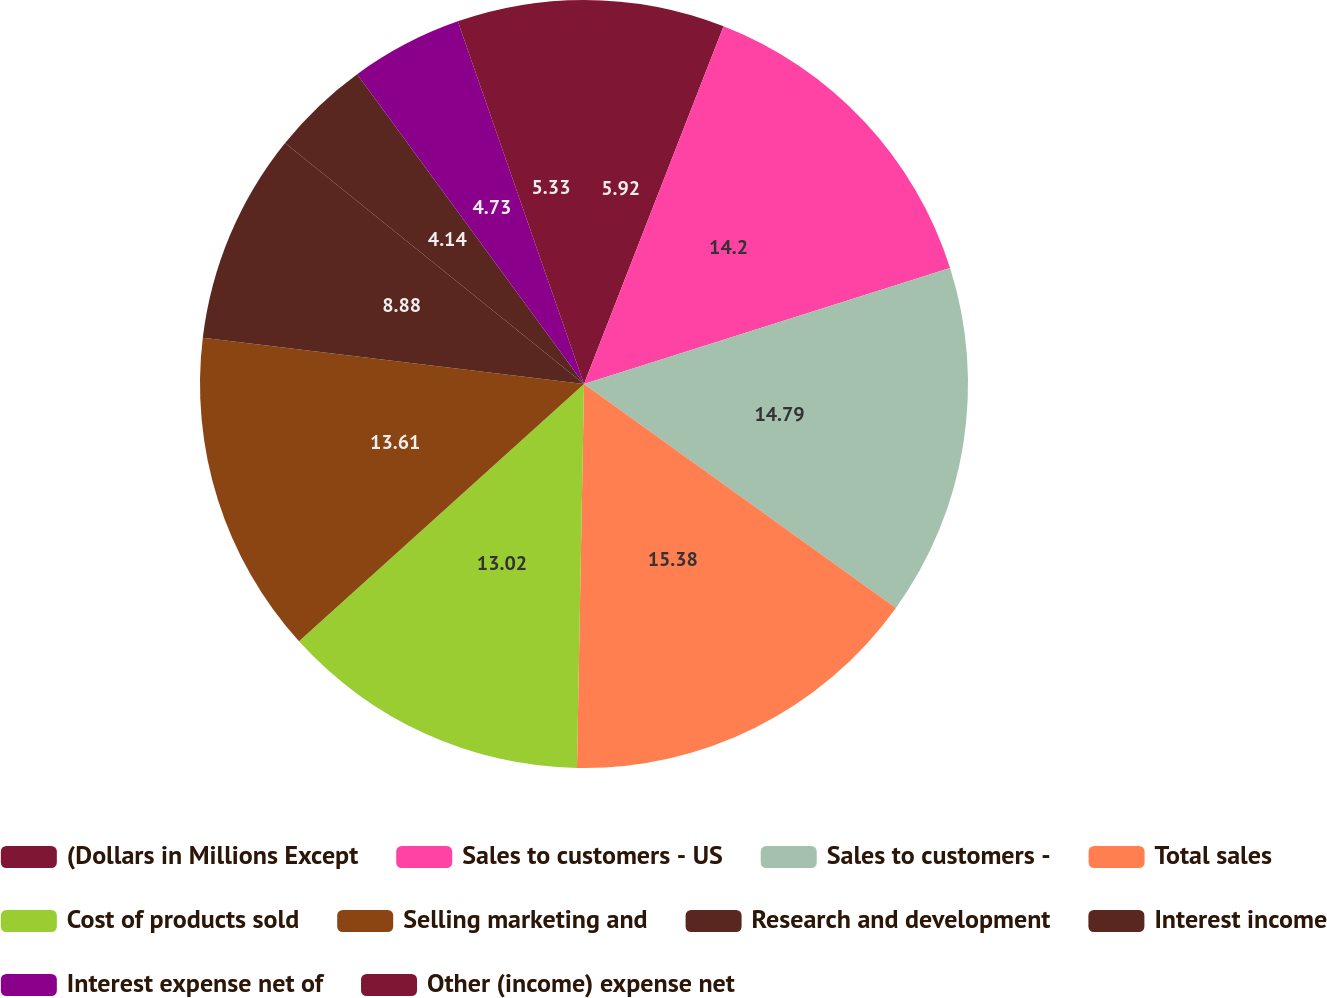Convert chart to OTSL. <chart><loc_0><loc_0><loc_500><loc_500><pie_chart><fcel>(Dollars in Millions Except<fcel>Sales to customers - US<fcel>Sales to customers -<fcel>Total sales<fcel>Cost of products sold<fcel>Selling marketing and<fcel>Research and development<fcel>Interest income<fcel>Interest expense net of<fcel>Other (income) expense net<nl><fcel>5.92%<fcel>14.2%<fcel>14.79%<fcel>15.38%<fcel>13.02%<fcel>13.61%<fcel>8.88%<fcel>4.14%<fcel>4.73%<fcel>5.33%<nl></chart> 